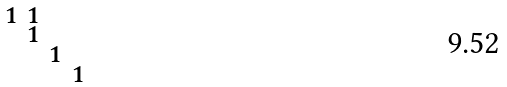Convert formula to latex. <formula><loc_0><loc_0><loc_500><loc_500>\begin{smallmatrix} 1 & 1 & & \\ & 1 & & \\ & & 1 & \\ & & & 1 \\ \end{smallmatrix}</formula> 